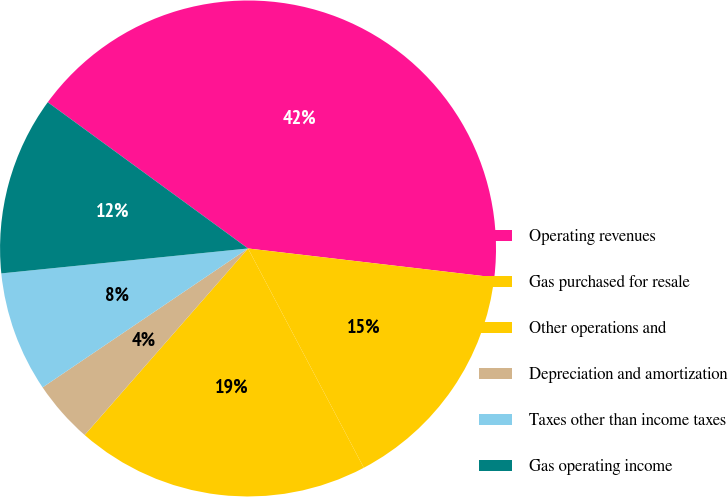Convert chart. <chart><loc_0><loc_0><loc_500><loc_500><pie_chart><fcel>Operating revenues<fcel>Gas purchased for resale<fcel>Other operations and<fcel>Depreciation and amortization<fcel>Taxes other than income taxes<fcel>Gas operating income<nl><fcel>41.82%<fcel>15.41%<fcel>19.18%<fcel>4.09%<fcel>7.86%<fcel>11.64%<nl></chart> 